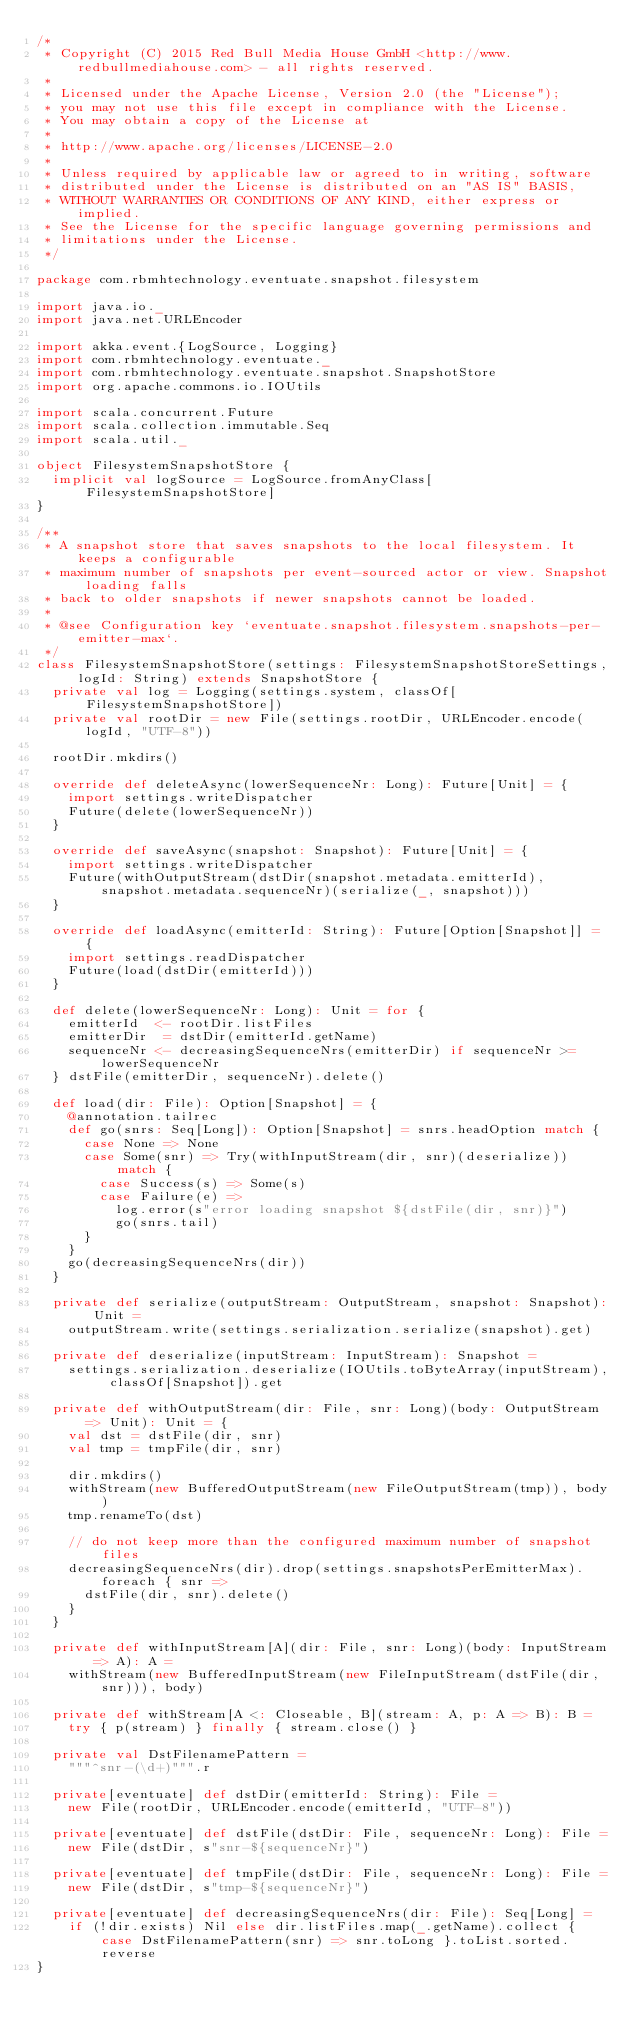Convert code to text. <code><loc_0><loc_0><loc_500><loc_500><_Scala_>/*
 * Copyright (C) 2015 Red Bull Media House GmbH <http://www.redbullmediahouse.com> - all rights reserved.
 *
 * Licensed under the Apache License, Version 2.0 (the "License");
 * you may not use this file except in compliance with the License.
 * You may obtain a copy of the License at
 *
 * http://www.apache.org/licenses/LICENSE-2.0
 *
 * Unless required by applicable law or agreed to in writing, software
 * distributed under the License is distributed on an "AS IS" BASIS,
 * WITHOUT WARRANTIES OR CONDITIONS OF ANY KIND, either express or implied.
 * See the License for the specific language governing permissions and
 * limitations under the License.
 */

package com.rbmhtechnology.eventuate.snapshot.filesystem

import java.io._
import java.net.URLEncoder

import akka.event.{LogSource, Logging}
import com.rbmhtechnology.eventuate._
import com.rbmhtechnology.eventuate.snapshot.SnapshotStore
import org.apache.commons.io.IOUtils

import scala.concurrent.Future
import scala.collection.immutable.Seq
import scala.util._

object FilesystemSnapshotStore {
  implicit val logSource = LogSource.fromAnyClass[FilesystemSnapshotStore]
}

/**
 * A snapshot store that saves snapshots to the local filesystem. It keeps a configurable
 * maximum number of snapshots per event-sourced actor or view. Snapshot loading falls
 * back to older snapshots if newer snapshots cannot be loaded.
 *
 * @see Configuration key `eventuate.snapshot.filesystem.snapshots-per-emitter-max`.
 */
class FilesystemSnapshotStore(settings: FilesystemSnapshotStoreSettings, logId: String) extends SnapshotStore {
  private val log = Logging(settings.system, classOf[FilesystemSnapshotStore])
  private val rootDir = new File(settings.rootDir, URLEncoder.encode(logId, "UTF-8"))

  rootDir.mkdirs()

  override def deleteAsync(lowerSequenceNr: Long): Future[Unit] = {
    import settings.writeDispatcher
    Future(delete(lowerSequenceNr))
  }

  override def saveAsync(snapshot: Snapshot): Future[Unit] = {
    import settings.writeDispatcher
    Future(withOutputStream(dstDir(snapshot.metadata.emitterId), snapshot.metadata.sequenceNr)(serialize(_, snapshot)))
  }

  override def loadAsync(emitterId: String): Future[Option[Snapshot]] = {
    import settings.readDispatcher
    Future(load(dstDir(emitterId)))
  }

  def delete(lowerSequenceNr: Long): Unit = for {
    emitterId  <- rootDir.listFiles
    emitterDir  = dstDir(emitterId.getName)
    sequenceNr <- decreasingSequenceNrs(emitterDir) if sequenceNr >= lowerSequenceNr
  } dstFile(emitterDir, sequenceNr).delete()

  def load(dir: File): Option[Snapshot] = {
    @annotation.tailrec
    def go(snrs: Seq[Long]): Option[Snapshot] = snrs.headOption match {
      case None => None
      case Some(snr) => Try(withInputStream(dir, snr)(deserialize)) match {
        case Success(s) => Some(s)
        case Failure(e) =>
          log.error(s"error loading snapshot ${dstFile(dir, snr)}")
          go(snrs.tail)
      }
    }
    go(decreasingSequenceNrs(dir))
  }

  private def serialize(outputStream: OutputStream, snapshot: Snapshot): Unit =
    outputStream.write(settings.serialization.serialize(snapshot).get)

  private def deserialize(inputStream: InputStream): Snapshot =
    settings.serialization.deserialize(IOUtils.toByteArray(inputStream), classOf[Snapshot]).get

  private def withOutputStream(dir: File, snr: Long)(body: OutputStream => Unit): Unit = {
    val dst = dstFile(dir, snr)
    val tmp = tmpFile(dir, snr)

    dir.mkdirs()
    withStream(new BufferedOutputStream(new FileOutputStream(tmp)), body)
    tmp.renameTo(dst)

    // do not keep more than the configured maximum number of snapshot files
    decreasingSequenceNrs(dir).drop(settings.snapshotsPerEmitterMax).foreach { snr =>
      dstFile(dir, snr).delete()
    }
  }

  private def withInputStream[A](dir: File, snr: Long)(body: InputStream => A): A =
    withStream(new BufferedInputStream(new FileInputStream(dstFile(dir, snr))), body)

  private def withStream[A <: Closeable, B](stream: A, p: A => B): B =
    try { p(stream) } finally { stream.close() }

  private val DstFilenamePattern =
    """^snr-(\d+)""".r

  private[eventuate] def dstDir(emitterId: String): File =
    new File(rootDir, URLEncoder.encode(emitterId, "UTF-8"))

  private[eventuate] def dstFile(dstDir: File, sequenceNr: Long): File =
    new File(dstDir, s"snr-${sequenceNr}")

  private[eventuate] def tmpFile(dstDir: File, sequenceNr: Long): File =
    new File(dstDir, s"tmp-${sequenceNr}")

  private[eventuate] def decreasingSequenceNrs(dir: File): Seq[Long] =
    if (!dir.exists) Nil else dir.listFiles.map(_.getName).collect { case DstFilenamePattern(snr) => snr.toLong }.toList.sorted.reverse
}
</code> 